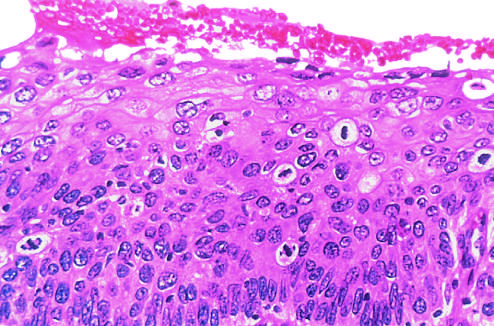what does high-power view of another region show?
Answer the question using a single word or phrase. Failure of normal differentiation 